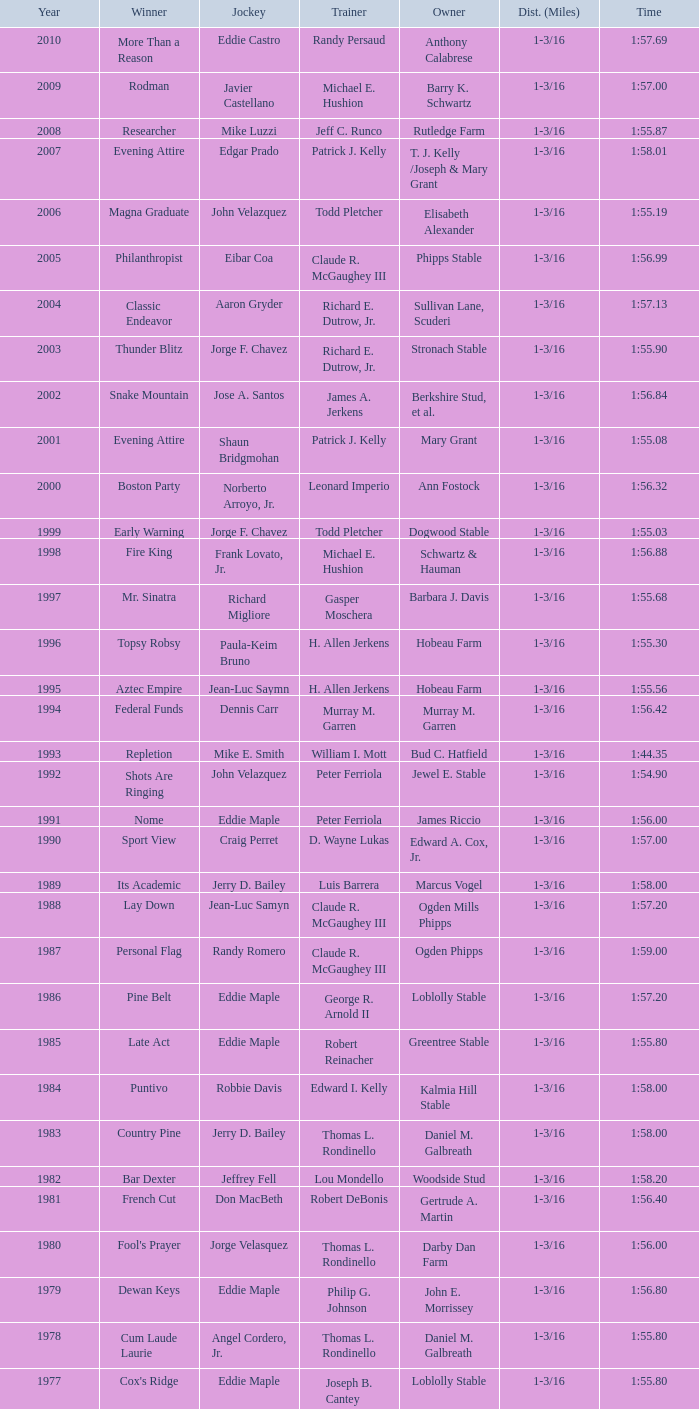Who was the jockey for the winning horse Helioptic? Paul Miller. 